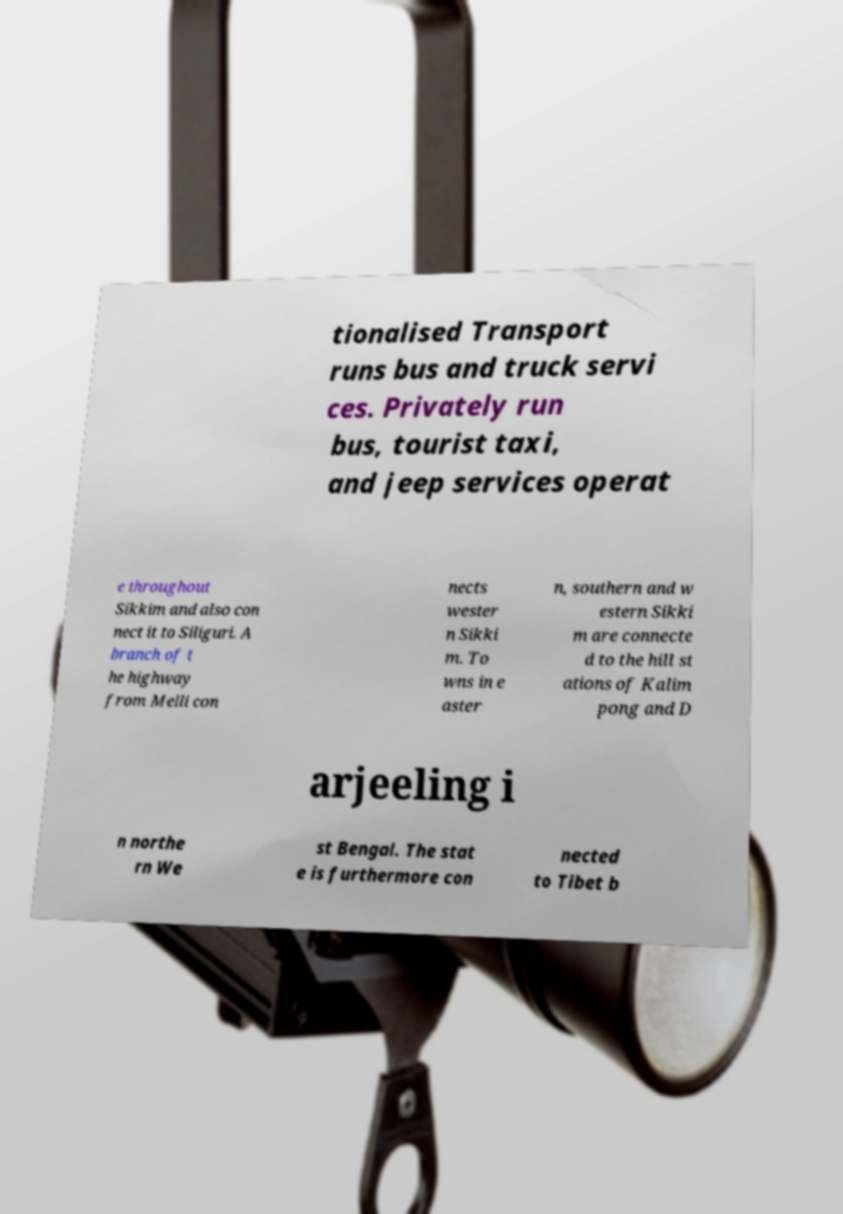Can you read and provide the text displayed in the image?This photo seems to have some interesting text. Can you extract and type it out for me? tionalised Transport runs bus and truck servi ces. Privately run bus, tourist taxi, and jeep services operat e throughout Sikkim and also con nect it to Siliguri. A branch of t he highway from Melli con nects wester n Sikki m. To wns in e aster n, southern and w estern Sikki m are connecte d to the hill st ations of Kalim pong and D arjeeling i n northe rn We st Bengal. The stat e is furthermore con nected to Tibet b 